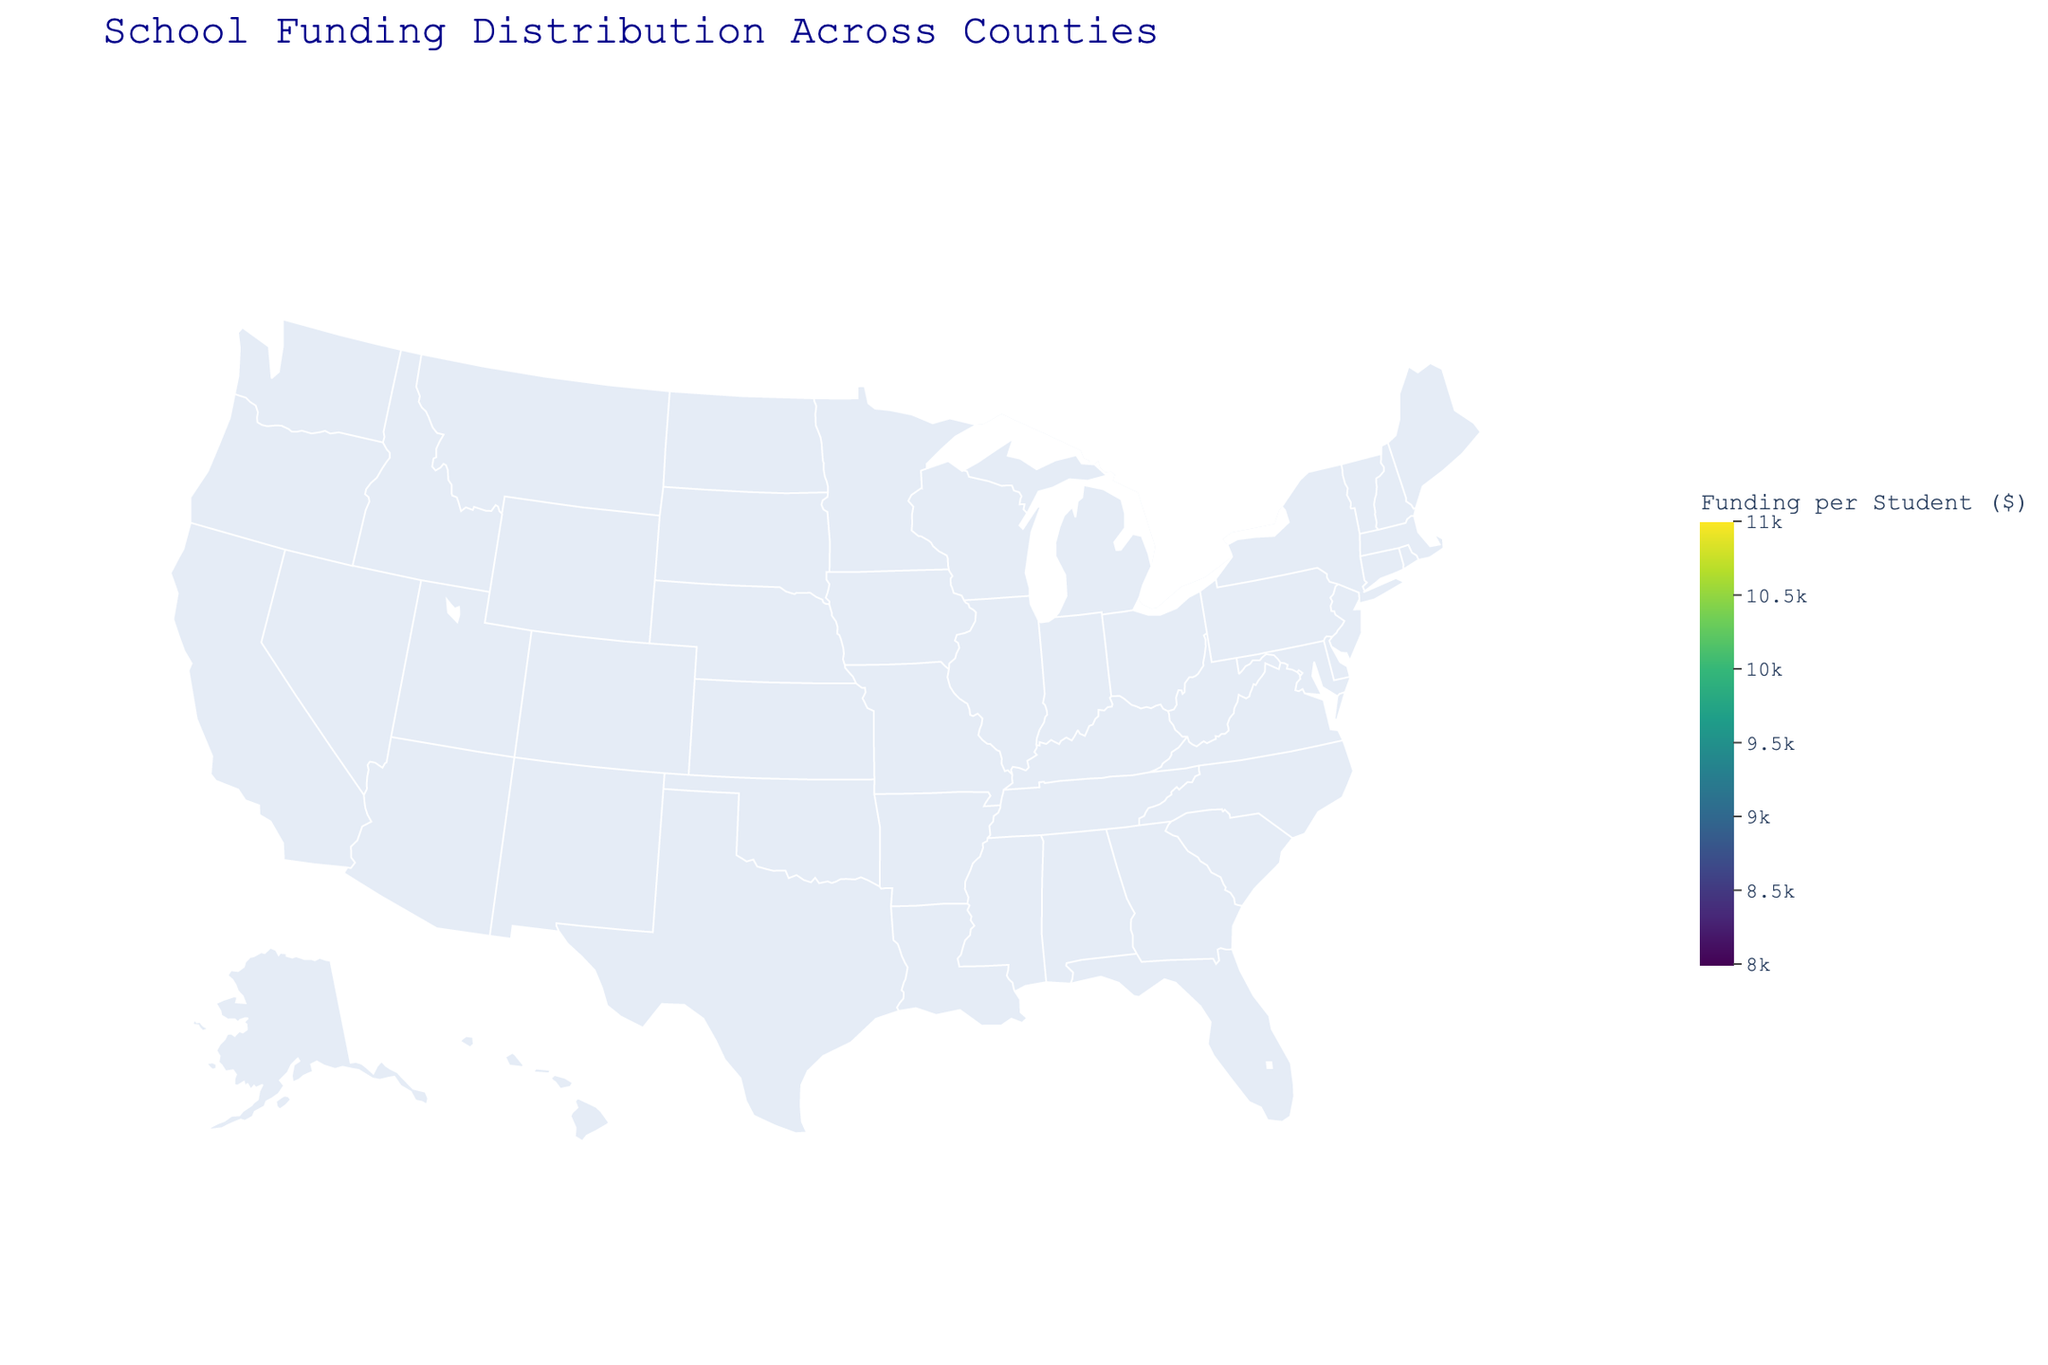How much funding per student does Jefferson County receive? The plot provides a color-coded representation of school funding per student for each county. Hover over Jefferson County to see the exact funding amount.
Answer: $9,850 Which county has the highest funding per student? Identify the county with the darkest shading on the color scale, which indicates higher funding. Hover over the darkest colored county to get the exact value.
Answer: Franklin County How much more funding per student does Franklin County receive compared to Monroe County? Find the funding amounts for both counties by hovering over them on the map. Subtract Monroe County's funding from Franklin County's.
Answer: $1,700 What is the average funding per student across all counties? Identify the funding amounts for all counties by hovering over them. Sum these amounts and divide by the number of counties.
Answer: $9,268.67 Are there any counties with funding per student below $9,000? Hover over each county and note the funding amounts. Identify any counties where the funding is less than $9,000.
Answer: Yes (Madison, Monroe, Harrison) Which county receives closer funding to the state average, Polk or Riverside? Calculate the state average funding per student. Compare the funding amounts of Polk and Riverside Counties to the state average to see which is closer. Explain the comparison.
Answer: Riverside Which counties have a funding per student value within $100 of $9,000? Hover over the counties to find those with funding amounts ranging from $8,900 to $9,100.
Answer: Washington County and Adams County What is the funding range (difference between the highest and lowest funding per student) across the counties? Identify the highest and lowest funding amounts by hovering over the counties and subtract the lowest amount from the highest amount.
Answer: $1,700 How does the funding for Adams County compare to Liberty County? Hover over Adams County and Liberty County to note their respective funding amounts. Compare the two values to determine which is greater.
Answer: Adams County has more Which counties have funding per student closer to $10,000? Hover over each county and note the funding amounts. Identify counties with funding close to $10,000.
Answer: Franklin County, Clay County 